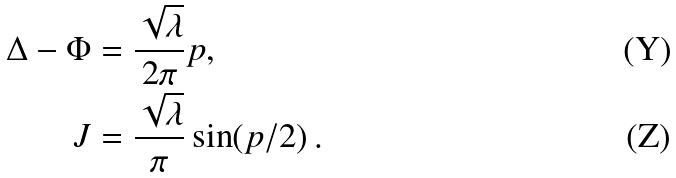Convert formula to latex. <formula><loc_0><loc_0><loc_500><loc_500>\Delta - \Phi & = \frac { \sqrt { \lambda } } { 2 \pi } p , \\ J & = \frac { \sqrt { \lambda } } { \pi } \sin ( p / 2 ) \, .</formula> 